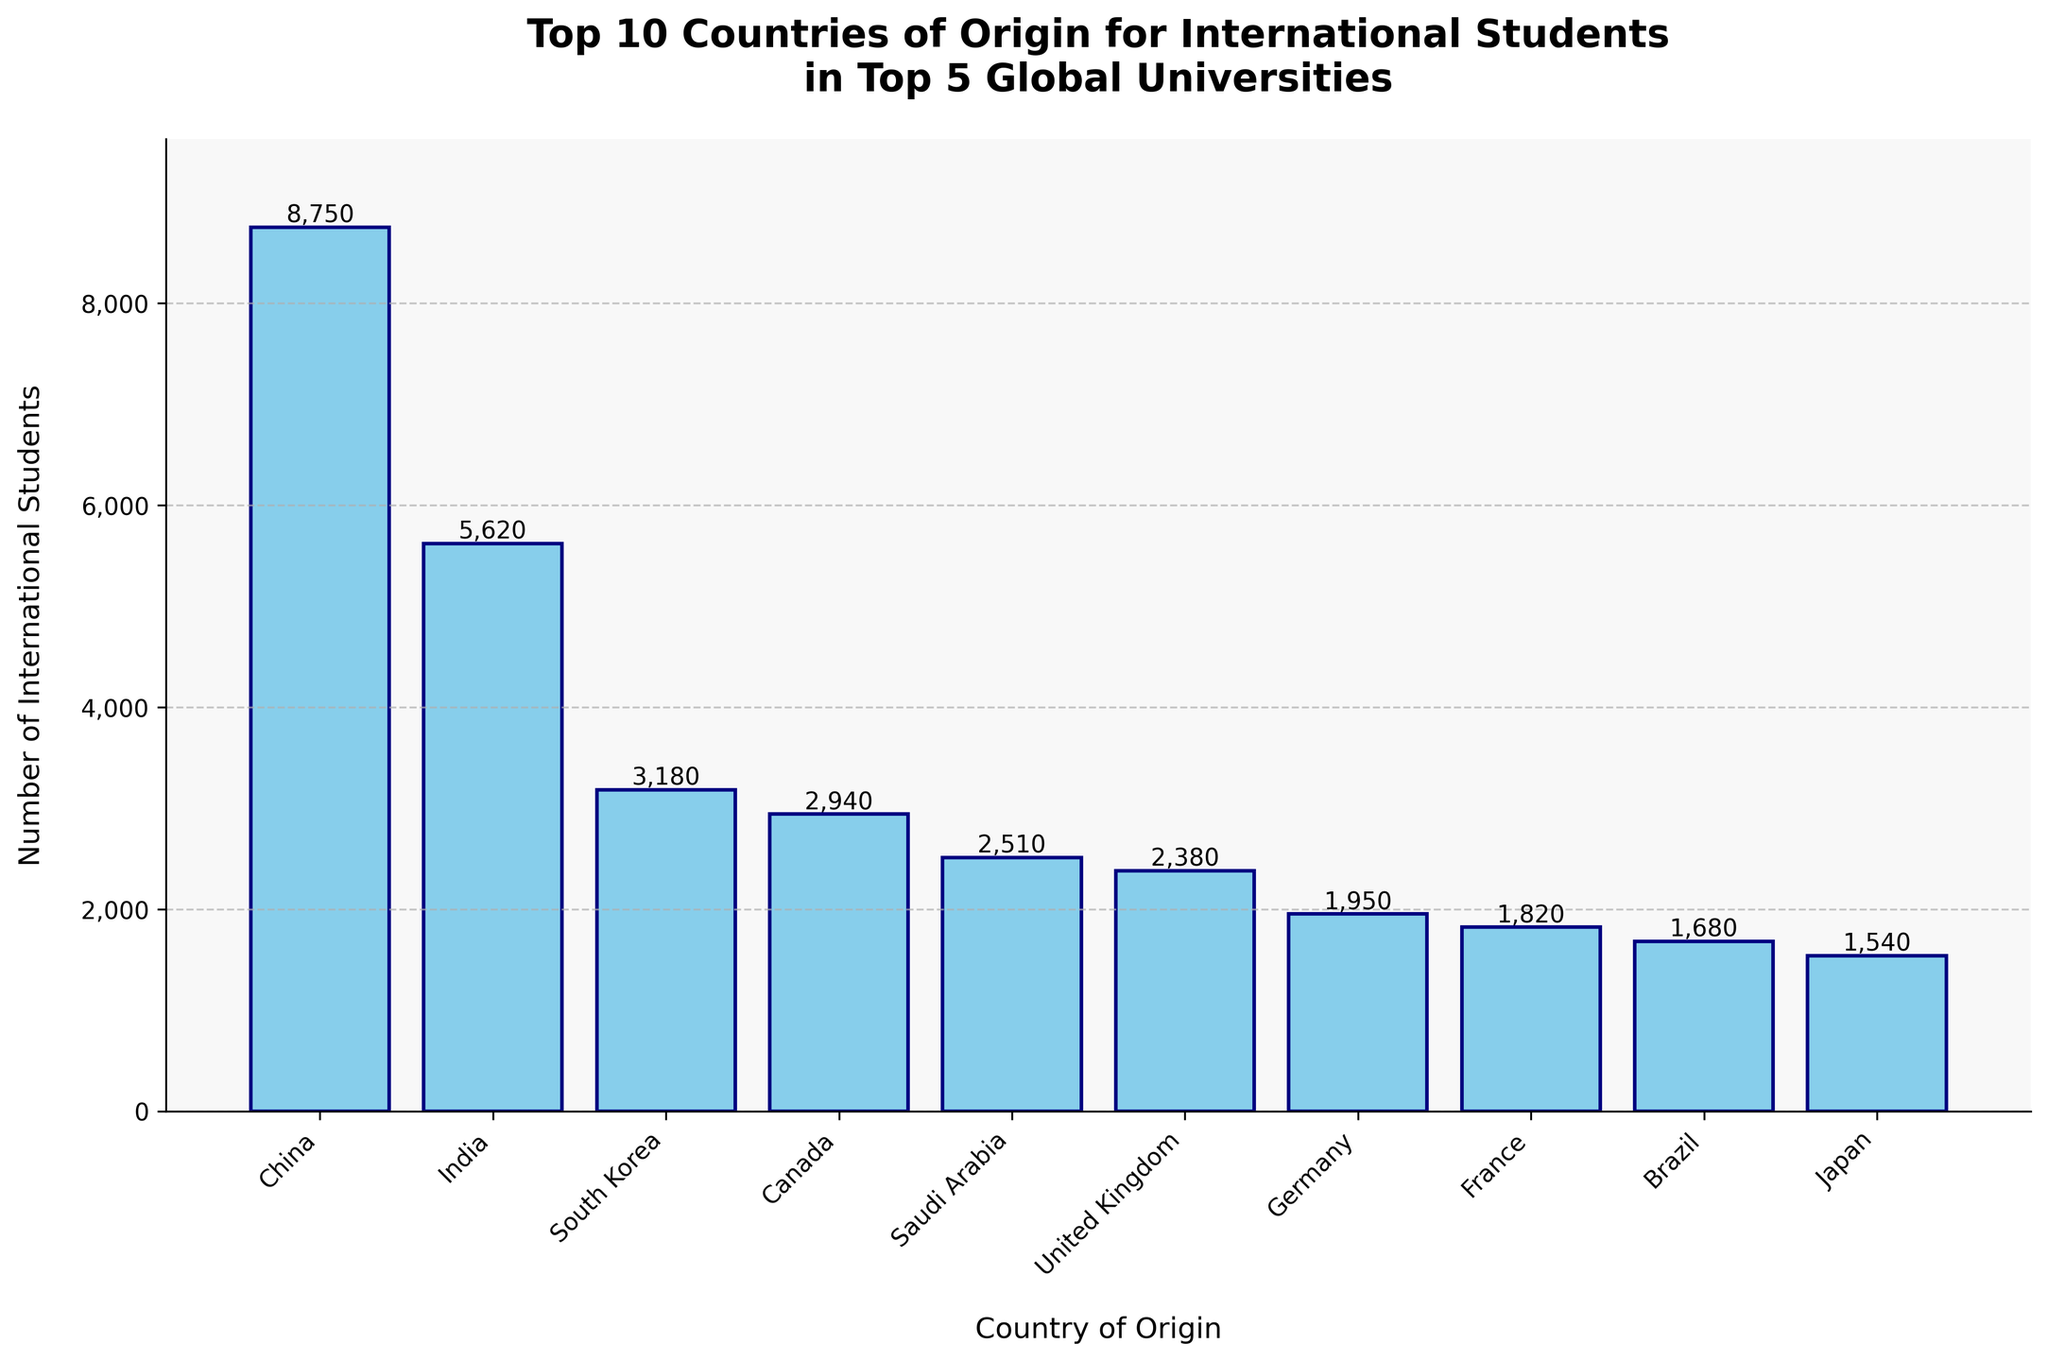Which country has the highest number of international students in the top 5 global universities? Observing the heights of the bars in the chart, the tallest bar represents China with 8750 students.
Answer: China Which two countries have the smallest number of international students among the top 10 countries? Look at the two shortest bars in the chart, which are for Saudi Arabia (2510) and the United Kingdom (2380).
Answer: Saudi Arabia and United Kingdom What is the total number of international students from the top 3 countries of origin? Add the values for China (8750), India (5620), and South Korea (3180): 8750 + 5620 + 3180 = 17550.
Answer: 17550 How many more international students are there from China compared to Germany? Find the difference between the number of students from China (8750) and Germany (1950): 8750 - 1950 = 6800.
Answer: 6800 What is the average number of international students from the top 5 countries of origin? Sum the students from the top 5 countries: 8750 (China) + 5620 (India) + 3180 (South Korea) + 2940 (Canada) + 2510 (Saudi Arabia) = 23000. Then divide by 5: 23000 / 5 = 4600.
Answer: 4600 Which country has fewer international students, Japan or Singapore? Compare the bars for Japan (1540) and Singapore (1420), and note that Singapore has fewer students.
Answer: Singapore By how much does the number of international students from China exceed the combined total of students from Brazil and Mexico? Calculate the total for Brazil and Mexico: 1680 (Brazil) + 1350 (Mexico) = 3030. Then find the difference between China's total (8750) and this combined value: 8750 - 3030 = 5720.
Answer: 5720 Which country is ranked fifth in the number of international students? The fifth highest bar corresponds to Saudi Arabia with 2510 students.
Answer: Saudi Arabia What is the percentage difference in the number of international students from India compared to South Korea? Calculate the difference: 5620 - 3180 = 2440. Then find the percentage difference relative to South Korea's number: (2440 / 3180) * 100 = 76.73%.
Answer: 76.73% Are there more international students from Canada or France, and by how many? Compare the bars and note that Canada (2940) has more students than France (1820). The difference is 2940 - 1820 = 1120.
Answer: Canada by 1120 